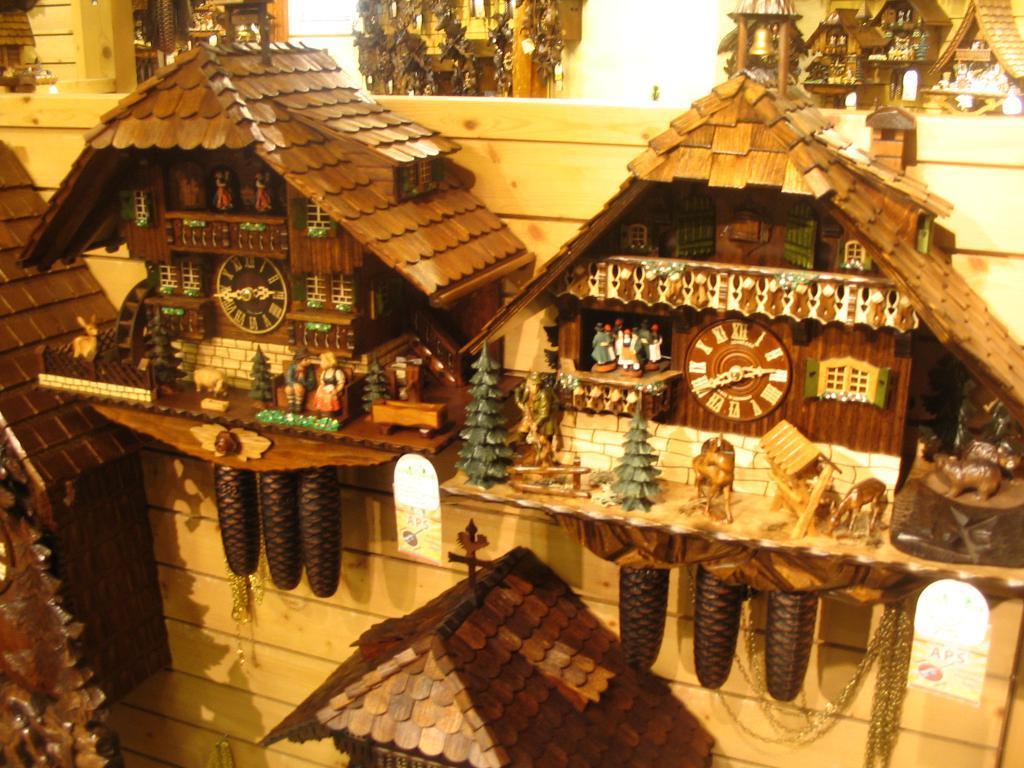How would you summarize this image in a sentence or two? In the foreground of this image, there are rooster clocks to the wooden wall. In the background, there are many rooster clocks. 